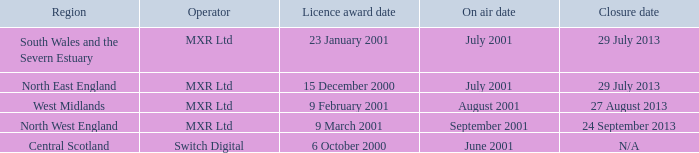What is the license award date for North East England? 15 December 2000. 